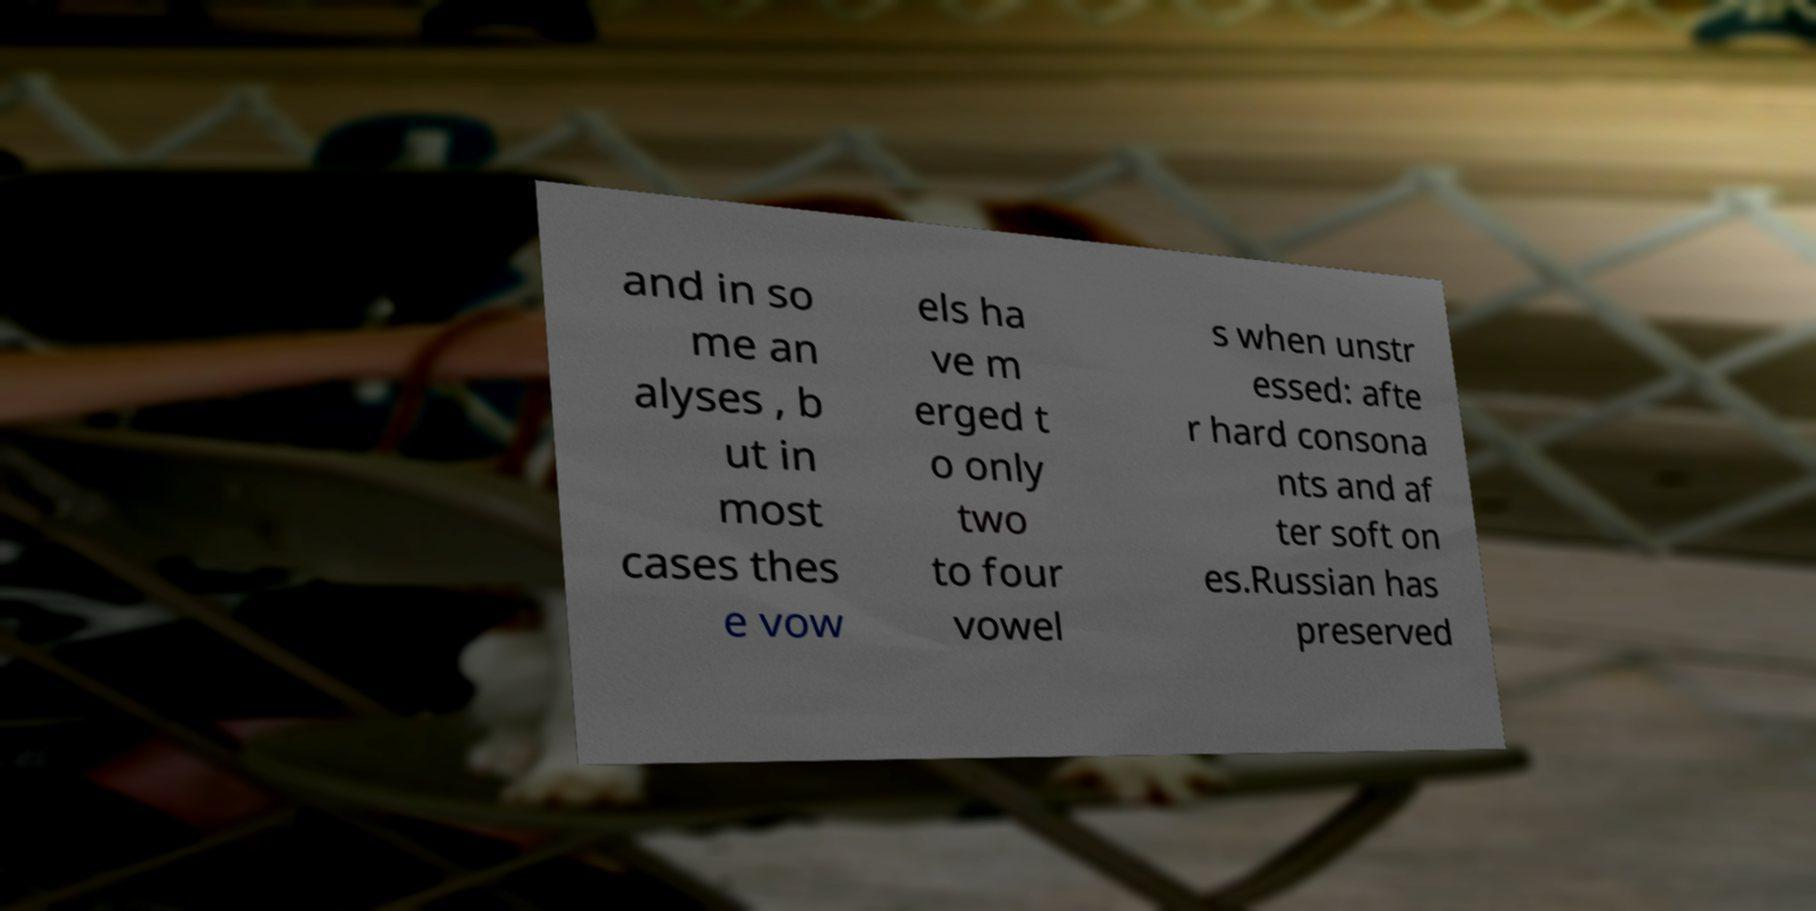For documentation purposes, I need the text within this image transcribed. Could you provide that? and in so me an alyses , b ut in most cases thes e vow els ha ve m erged t o only two to four vowel s when unstr essed: afte r hard consona nts and af ter soft on es.Russian has preserved 